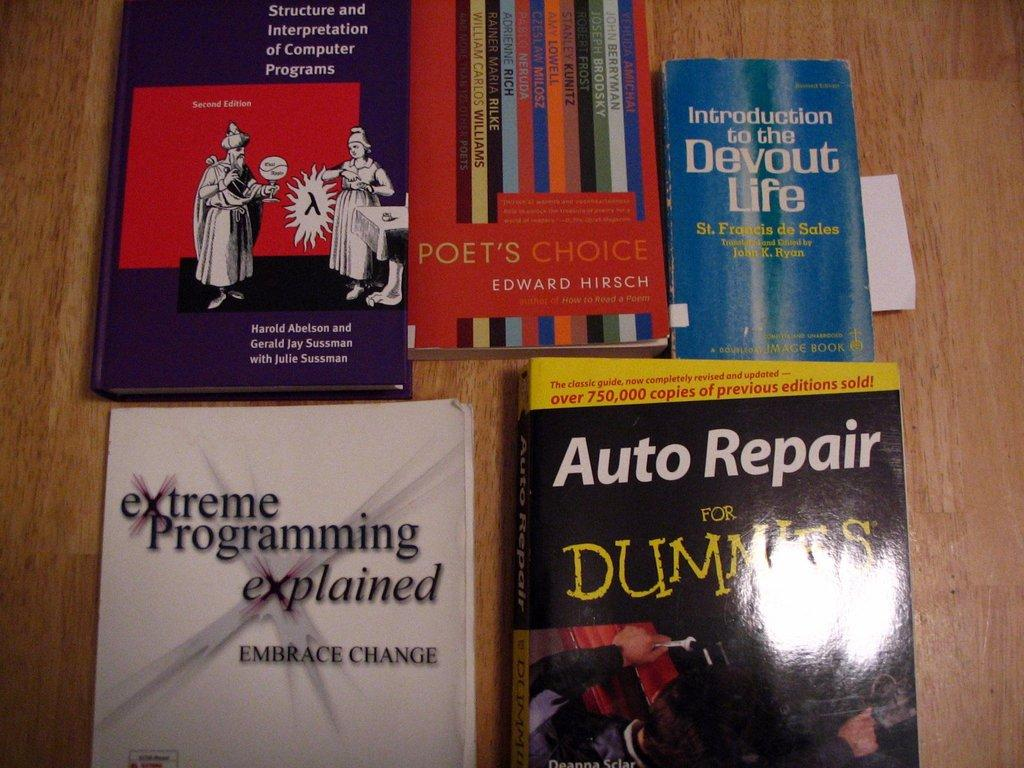Provide a one-sentence caption for the provided image. The books on display include Auto Repair for Dummies. 